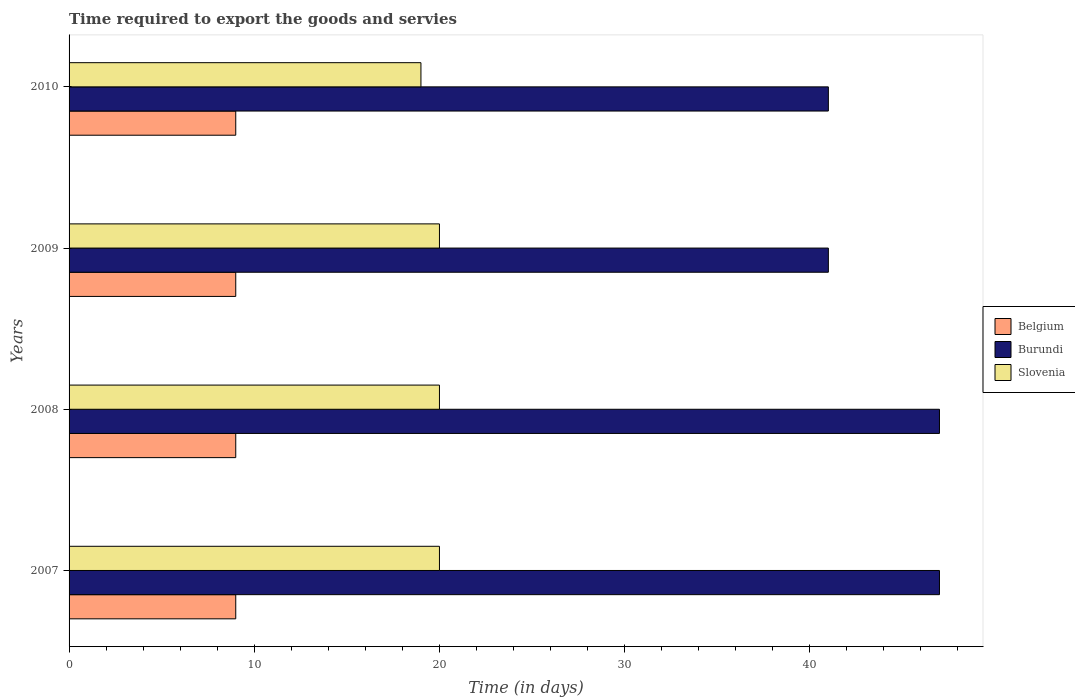How many groups of bars are there?
Your response must be concise. 4. Are the number of bars per tick equal to the number of legend labels?
Ensure brevity in your answer.  Yes. How many bars are there on the 3rd tick from the top?
Make the answer very short. 3. What is the label of the 4th group of bars from the top?
Provide a short and direct response. 2007. What is the number of days required to export the goods and services in Belgium in 2010?
Give a very brief answer. 9. Across all years, what is the maximum number of days required to export the goods and services in Burundi?
Your response must be concise. 47. Across all years, what is the minimum number of days required to export the goods and services in Burundi?
Provide a short and direct response. 41. In which year was the number of days required to export the goods and services in Belgium maximum?
Make the answer very short. 2007. What is the total number of days required to export the goods and services in Burundi in the graph?
Provide a succinct answer. 176. What is the difference between the number of days required to export the goods and services in Burundi in 2008 and that in 2010?
Ensure brevity in your answer.  6. What is the difference between the number of days required to export the goods and services in Burundi in 2010 and the number of days required to export the goods and services in Belgium in 2007?
Your response must be concise. 32. What is the average number of days required to export the goods and services in Slovenia per year?
Provide a succinct answer. 19.75. In the year 2009, what is the difference between the number of days required to export the goods and services in Slovenia and number of days required to export the goods and services in Belgium?
Make the answer very short. 11. In how many years, is the number of days required to export the goods and services in Slovenia greater than 24 days?
Your answer should be very brief. 0. What is the ratio of the number of days required to export the goods and services in Slovenia in 2008 to that in 2010?
Ensure brevity in your answer.  1.05. Is the number of days required to export the goods and services in Burundi in 2007 less than that in 2009?
Provide a short and direct response. No. What is the difference between the highest and the lowest number of days required to export the goods and services in Belgium?
Give a very brief answer. 0. In how many years, is the number of days required to export the goods and services in Slovenia greater than the average number of days required to export the goods and services in Slovenia taken over all years?
Offer a terse response. 3. Is the sum of the number of days required to export the goods and services in Belgium in 2007 and 2009 greater than the maximum number of days required to export the goods and services in Slovenia across all years?
Give a very brief answer. No. What does the 2nd bar from the top in 2008 represents?
Your answer should be compact. Burundi. What does the 3rd bar from the bottom in 2010 represents?
Offer a very short reply. Slovenia. Is it the case that in every year, the sum of the number of days required to export the goods and services in Belgium and number of days required to export the goods and services in Slovenia is greater than the number of days required to export the goods and services in Burundi?
Keep it short and to the point. No. Does the graph contain any zero values?
Ensure brevity in your answer.  No. Does the graph contain grids?
Provide a short and direct response. No. Where does the legend appear in the graph?
Make the answer very short. Center right. How many legend labels are there?
Make the answer very short. 3. How are the legend labels stacked?
Keep it short and to the point. Vertical. What is the title of the graph?
Offer a terse response. Time required to export the goods and servies. What is the label or title of the X-axis?
Provide a short and direct response. Time (in days). What is the label or title of the Y-axis?
Provide a short and direct response. Years. What is the Time (in days) of Slovenia in 2007?
Your response must be concise. 20. What is the Time (in days) of Belgium in 2009?
Make the answer very short. 9. What is the Time (in days) of Burundi in 2010?
Your answer should be compact. 41. What is the Time (in days) of Slovenia in 2010?
Make the answer very short. 19. Across all years, what is the maximum Time (in days) in Belgium?
Your answer should be very brief. 9. Across all years, what is the maximum Time (in days) in Slovenia?
Give a very brief answer. 20. Across all years, what is the minimum Time (in days) in Slovenia?
Your answer should be compact. 19. What is the total Time (in days) of Burundi in the graph?
Give a very brief answer. 176. What is the total Time (in days) in Slovenia in the graph?
Provide a succinct answer. 79. What is the difference between the Time (in days) in Burundi in 2007 and that in 2008?
Your answer should be compact. 0. What is the difference between the Time (in days) in Burundi in 2007 and that in 2009?
Give a very brief answer. 6. What is the difference between the Time (in days) in Burundi in 2007 and that in 2010?
Offer a very short reply. 6. What is the difference between the Time (in days) of Slovenia in 2007 and that in 2010?
Your answer should be compact. 1. What is the difference between the Time (in days) in Burundi in 2008 and that in 2009?
Offer a very short reply. 6. What is the difference between the Time (in days) of Slovenia in 2008 and that in 2009?
Your answer should be compact. 0. What is the difference between the Time (in days) of Belgium in 2008 and that in 2010?
Offer a very short reply. 0. What is the difference between the Time (in days) in Burundi in 2008 and that in 2010?
Keep it short and to the point. 6. What is the difference between the Time (in days) of Slovenia in 2008 and that in 2010?
Your answer should be very brief. 1. What is the difference between the Time (in days) in Belgium in 2009 and that in 2010?
Ensure brevity in your answer.  0. What is the difference between the Time (in days) of Burundi in 2009 and that in 2010?
Your answer should be very brief. 0. What is the difference between the Time (in days) of Belgium in 2007 and the Time (in days) of Burundi in 2008?
Keep it short and to the point. -38. What is the difference between the Time (in days) of Belgium in 2007 and the Time (in days) of Slovenia in 2008?
Give a very brief answer. -11. What is the difference between the Time (in days) of Burundi in 2007 and the Time (in days) of Slovenia in 2008?
Provide a short and direct response. 27. What is the difference between the Time (in days) in Belgium in 2007 and the Time (in days) in Burundi in 2009?
Your response must be concise. -32. What is the difference between the Time (in days) in Belgium in 2007 and the Time (in days) in Burundi in 2010?
Your answer should be compact. -32. What is the difference between the Time (in days) of Burundi in 2007 and the Time (in days) of Slovenia in 2010?
Your response must be concise. 28. What is the difference between the Time (in days) in Belgium in 2008 and the Time (in days) in Burundi in 2009?
Offer a terse response. -32. What is the difference between the Time (in days) in Belgium in 2008 and the Time (in days) in Burundi in 2010?
Offer a terse response. -32. What is the difference between the Time (in days) in Belgium in 2009 and the Time (in days) in Burundi in 2010?
Provide a short and direct response. -32. What is the difference between the Time (in days) in Belgium in 2009 and the Time (in days) in Slovenia in 2010?
Your answer should be compact. -10. What is the average Time (in days) of Belgium per year?
Provide a succinct answer. 9. What is the average Time (in days) of Slovenia per year?
Provide a short and direct response. 19.75. In the year 2007, what is the difference between the Time (in days) in Belgium and Time (in days) in Burundi?
Provide a succinct answer. -38. In the year 2007, what is the difference between the Time (in days) in Belgium and Time (in days) in Slovenia?
Provide a short and direct response. -11. In the year 2007, what is the difference between the Time (in days) of Burundi and Time (in days) of Slovenia?
Offer a very short reply. 27. In the year 2008, what is the difference between the Time (in days) in Belgium and Time (in days) in Burundi?
Your answer should be compact. -38. In the year 2008, what is the difference between the Time (in days) in Burundi and Time (in days) in Slovenia?
Ensure brevity in your answer.  27. In the year 2009, what is the difference between the Time (in days) of Belgium and Time (in days) of Burundi?
Give a very brief answer. -32. In the year 2010, what is the difference between the Time (in days) of Belgium and Time (in days) of Burundi?
Offer a very short reply. -32. In the year 2010, what is the difference between the Time (in days) of Belgium and Time (in days) of Slovenia?
Offer a very short reply. -10. In the year 2010, what is the difference between the Time (in days) of Burundi and Time (in days) of Slovenia?
Your response must be concise. 22. What is the ratio of the Time (in days) in Slovenia in 2007 to that in 2008?
Keep it short and to the point. 1. What is the ratio of the Time (in days) of Belgium in 2007 to that in 2009?
Give a very brief answer. 1. What is the ratio of the Time (in days) of Burundi in 2007 to that in 2009?
Ensure brevity in your answer.  1.15. What is the ratio of the Time (in days) of Belgium in 2007 to that in 2010?
Keep it short and to the point. 1. What is the ratio of the Time (in days) in Burundi in 2007 to that in 2010?
Offer a very short reply. 1.15. What is the ratio of the Time (in days) in Slovenia in 2007 to that in 2010?
Offer a terse response. 1.05. What is the ratio of the Time (in days) of Belgium in 2008 to that in 2009?
Your response must be concise. 1. What is the ratio of the Time (in days) of Burundi in 2008 to that in 2009?
Ensure brevity in your answer.  1.15. What is the ratio of the Time (in days) in Slovenia in 2008 to that in 2009?
Provide a succinct answer. 1. What is the ratio of the Time (in days) of Burundi in 2008 to that in 2010?
Your response must be concise. 1.15. What is the ratio of the Time (in days) in Slovenia in 2008 to that in 2010?
Your response must be concise. 1.05. What is the ratio of the Time (in days) of Slovenia in 2009 to that in 2010?
Offer a very short reply. 1.05. What is the difference between the highest and the second highest Time (in days) of Belgium?
Offer a very short reply. 0. What is the difference between the highest and the second highest Time (in days) in Slovenia?
Give a very brief answer. 0. What is the difference between the highest and the lowest Time (in days) in Slovenia?
Provide a short and direct response. 1. 